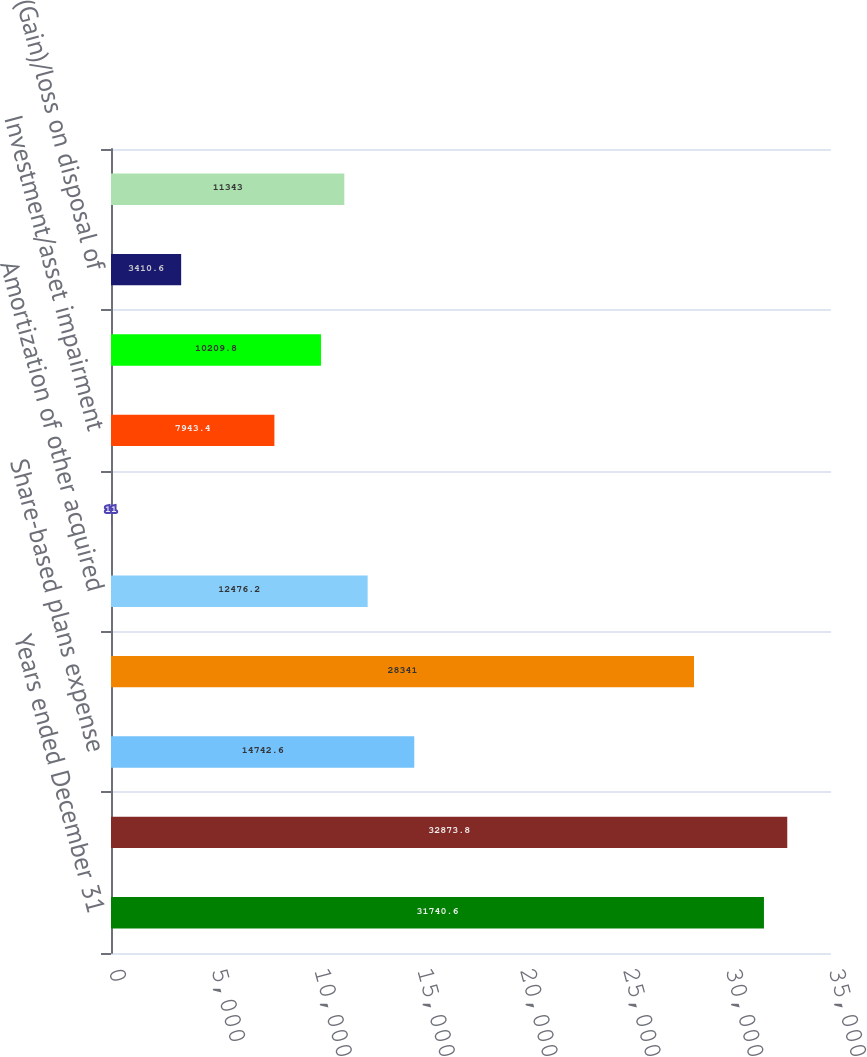Convert chart to OTSL. <chart><loc_0><loc_0><loc_500><loc_500><bar_chart><fcel>Years ended December 31<fcel>Net earnings<fcel>Share-based plans expense<fcel>Depreciation<fcel>Amortization of other acquired<fcel>Amortization of debt<fcel>Investment/asset impairment<fcel>Customer financing valuation<fcel>(Gain)/loss on disposal of<fcel>Excess tax benefits from<nl><fcel>31740.6<fcel>32873.8<fcel>14742.6<fcel>28341<fcel>12476.2<fcel>11<fcel>7943.4<fcel>10209.8<fcel>3410.6<fcel>11343<nl></chart> 